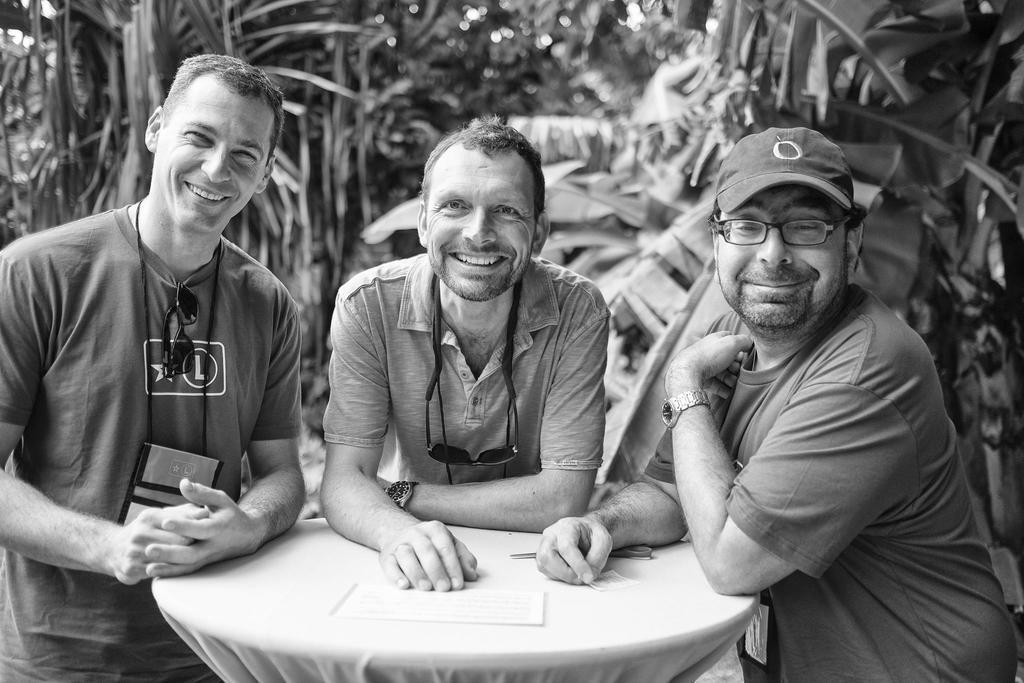How would you summarize this image in a sentence or two? In this image I can see three people standing and smiling. There is a table , on the table there is a paper and scissor. In the background there are trees. 